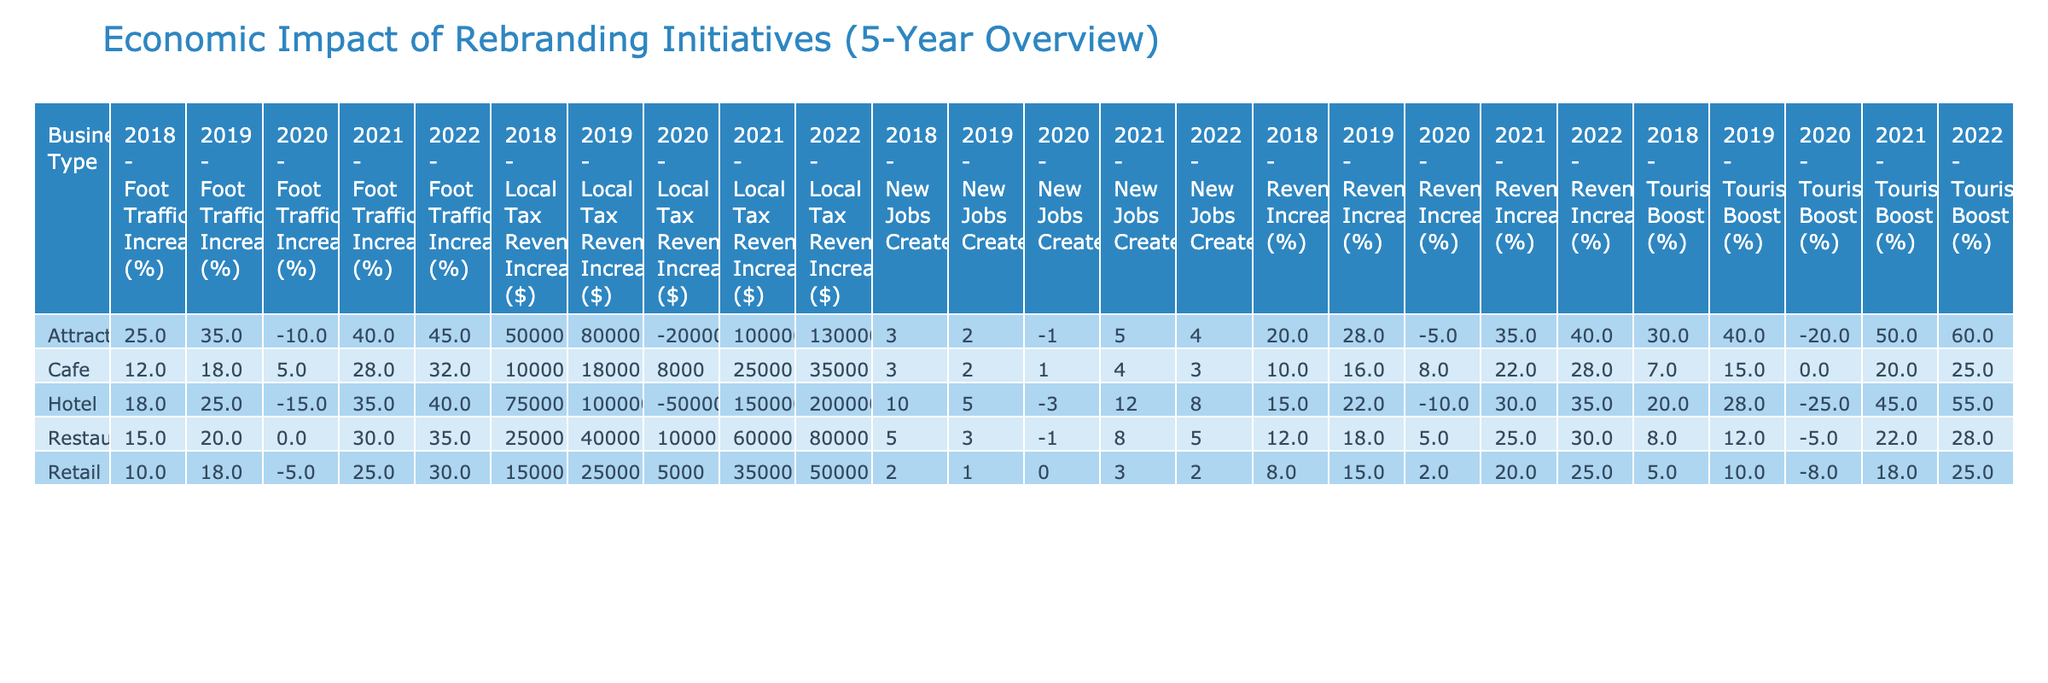What was the business type with the highest revenue increase in 2021? By examining the 'Revenue Increase (%)' column for the year 2021, we see that the 'Hotel' business type, Cityview Inn, had a revenue increase of 30%, which is the highest among all business types that year.
Answer: Hotel What is the average increase in local tax revenue for Cafes over the 5 years? To calculate the average, we can sum the local tax revenue increases for Cafes across all years: 10, 18, 8, 25, and 35, which equals 96. Then, we divide by the number of years (5). So, 96/5 = 19.2.
Answer: 19.2 Did foot traffic increase for the Harmony Museum in 2020? In the 'Foot Traffic Increase (%)' column for 2020 under Attractions, the value is -10, indicating a decrease in foot traffic that year.
Answer: No Which business type had consistent revenue increases over the 5 years? By reviewing each year's 'Revenue Increase (%)' for all business types, we note that the 'Café' saw increases of 10, 16, 8, 22, and 28. Each value is higher than the previous year, indicating consistent revenue growth.
Answer: Café What is the total number of new jobs created by Retail businesses from 2018 to 2022? We can sum the 'New Jobs Created' for Retail from 2018 (2), 2019 (1), 2020 (0), 2021 (3), and 2022 (2), giving us a total of 2 + 1 + 0 + 3 + 2 = 8.
Answer: 8 Was there a tourism boost for Heritage Museum in 2020? Looking at the 'Tourism Boost (%)' for Heritage Museum in 2020, the value is -20, indicating a decline in tourism that year.
Answer: No In which year did the Cityview Inn experience the highest local tax revenue increase? By checking the 'Local Tax Revenue Increase ($)' for Cityview Inn over the years, we find that 2022 had the highest amount of $200,000.
Answer: 2022 What is the average foot traffic increase for Restaurants between 2018 and 2022? Summing the foot traffic increases for Restaurants: 15, 20, 0, 30, and 35 gives us a total of 100. Dividing this by 5 years yields an average of 20.
Answer: 20 Which business type experienced a decline in revenue in 2020 and was it consistent across all businesses? In 2020, the Revenue Increase for Restaurants, Retail, and Hotels was negative, indicating declines; however, Cafes saw a slight increase. Thus, not all businesses faced declines.
Answer: No 